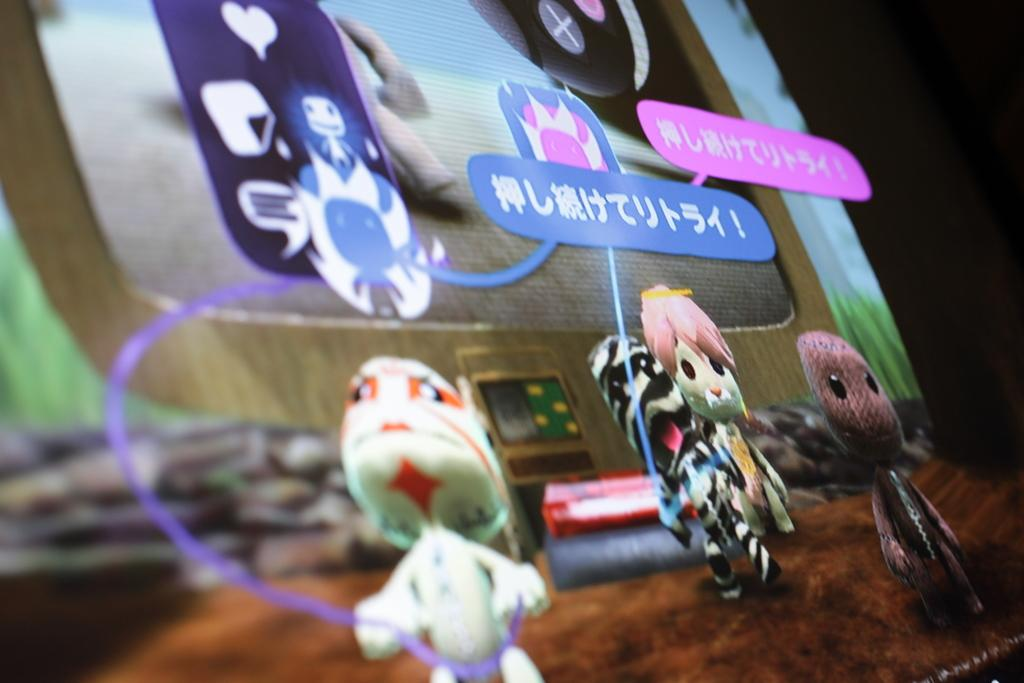What type of objects can be seen in the image? The image contains toy images. Is there any text present in the image? Yes, there is edited text in the image. What else can be found in the image besides toys and text? There are icons in the image. Can you describe the quality of the image on the left side? The left side of the image is slightly blurred. What type of wine is being served in the image? There is no wine present in the image; it contains toy images, edited text, and icons. Can you see any bushes in the image? There are no bushes present in the image. 